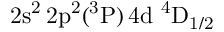Convert formula to latex. <formula><loc_0><loc_0><loc_500><loc_500>2 s ^ { 2 } \, 2 p ^ { 2 } ( ^ { 3 } P ) \, 4 d ^ { 4 } D _ { 1 / 2 }</formula> 